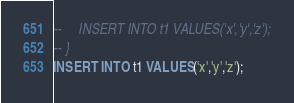Convert code to text. <code><loc_0><loc_0><loc_500><loc_500><_SQL_>--     INSERT INTO t1 VALUES('x','y','z');
-- }
INSERT INTO t1 VALUES('x','y','z');</code> 